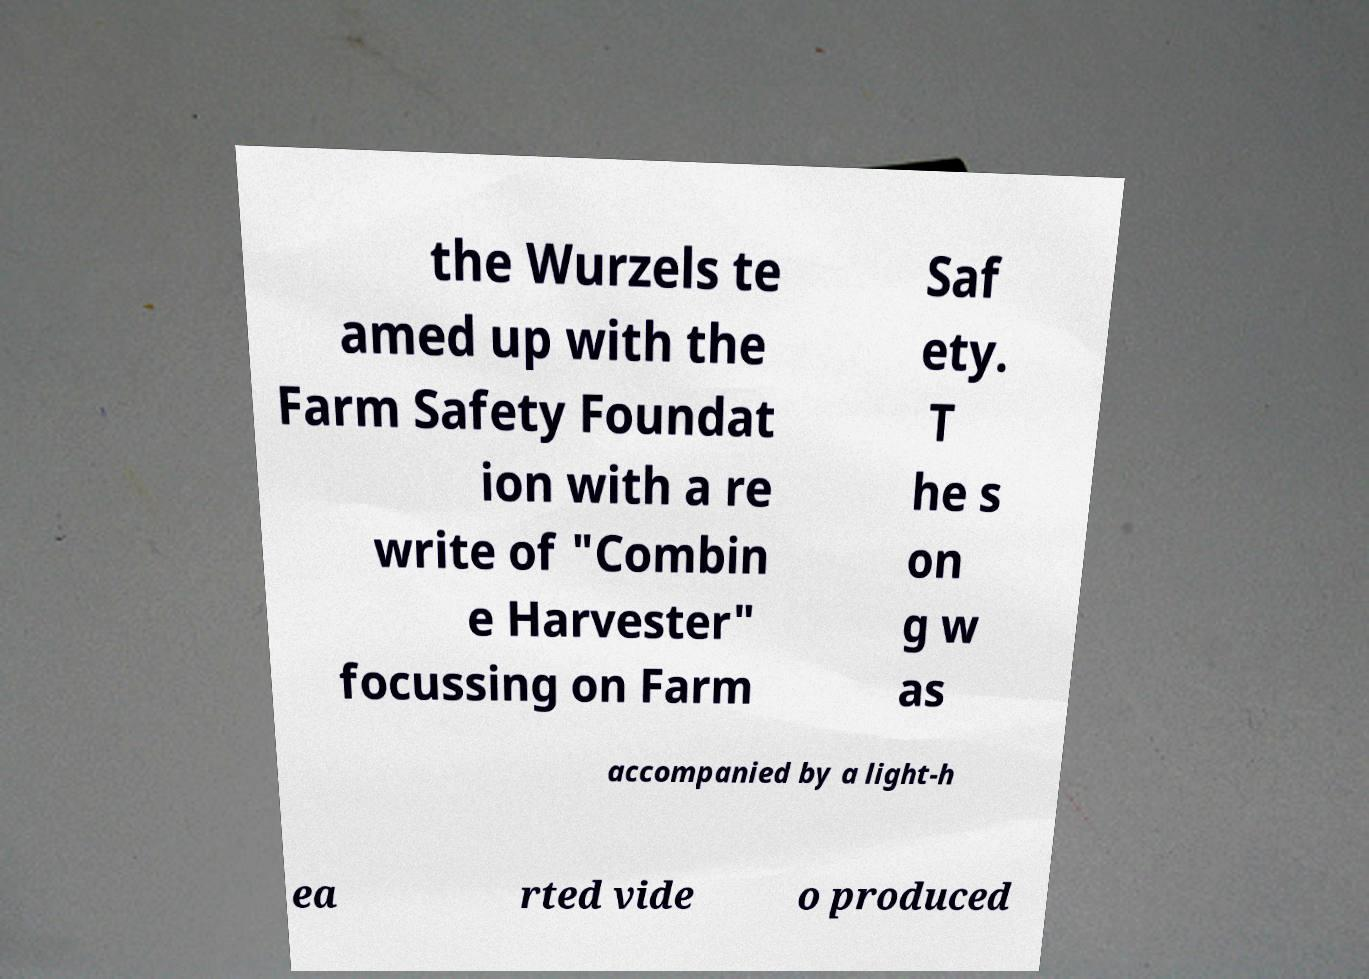Can you accurately transcribe the text from the provided image for me? the Wurzels te amed up with the Farm Safety Foundat ion with a re write of "Combin e Harvester" focussing on Farm Saf ety. T he s on g w as accompanied by a light-h ea rted vide o produced 